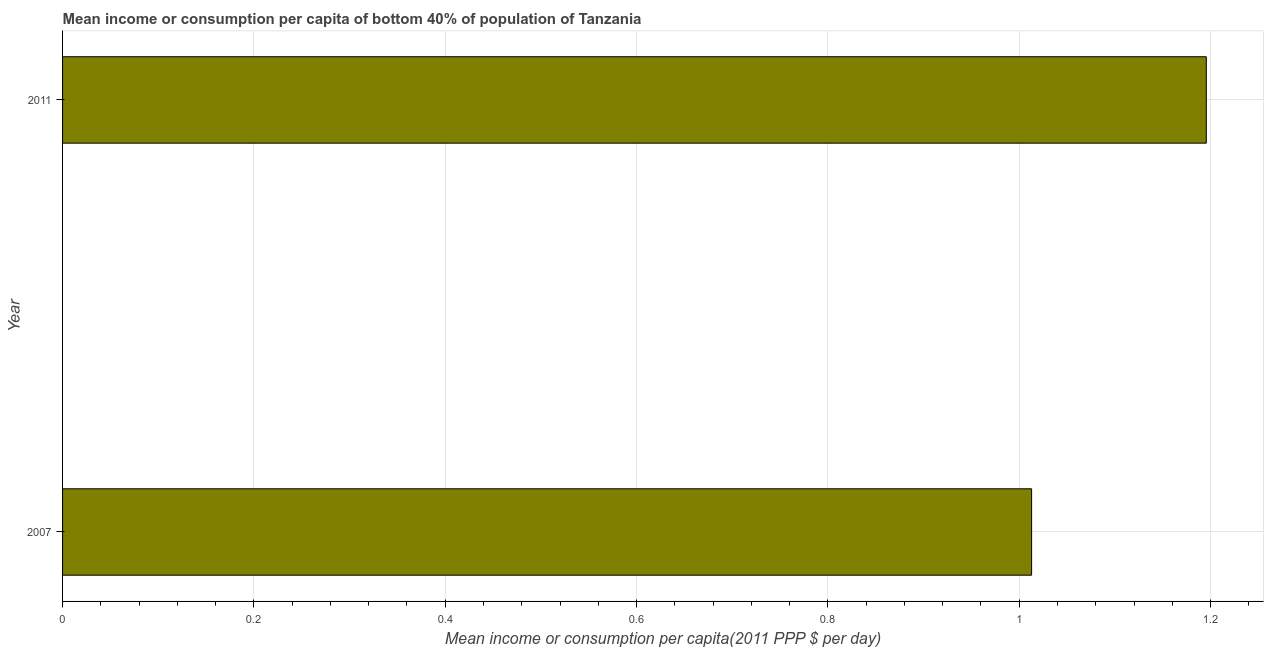Does the graph contain any zero values?
Your response must be concise. No. What is the title of the graph?
Your answer should be very brief. Mean income or consumption per capita of bottom 40% of population of Tanzania. What is the label or title of the X-axis?
Give a very brief answer. Mean income or consumption per capita(2011 PPP $ per day). What is the mean income or consumption in 2007?
Your answer should be very brief. 1.01. Across all years, what is the maximum mean income or consumption?
Give a very brief answer. 1.2. Across all years, what is the minimum mean income or consumption?
Keep it short and to the point. 1.01. In which year was the mean income or consumption maximum?
Your answer should be compact. 2011. What is the sum of the mean income or consumption?
Provide a short and direct response. 2.21. What is the difference between the mean income or consumption in 2007 and 2011?
Your answer should be very brief. -0.18. What is the average mean income or consumption per year?
Your answer should be compact. 1.1. What is the median mean income or consumption?
Make the answer very short. 1.1. In how many years, is the mean income or consumption greater than 0.36 $?
Make the answer very short. 2. Do a majority of the years between 2011 and 2007 (inclusive) have mean income or consumption greater than 0.88 $?
Ensure brevity in your answer.  No. What is the ratio of the mean income or consumption in 2007 to that in 2011?
Give a very brief answer. 0.85. Is the mean income or consumption in 2007 less than that in 2011?
Keep it short and to the point. Yes. How many years are there in the graph?
Keep it short and to the point. 2. What is the Mean income or consumption per capita(2011 PPP $ per day) in 2007?
Give a very brief answer. 1.01. What is the Mean income or consumption per capita(2011 PPP $ per day) in 2011?
Offer a terse response. 1.2. What is the difference between the Mean income or consumption per capita(2011 PPP $ per day) in 2007 and 2011?
Offer a terse response. -0.18. What is the ratio of the Mean income or consumption per capita(2011 PPP $ per day) in 2007 to that in 2011?
Ensure brevity in your answer.  0.85. 